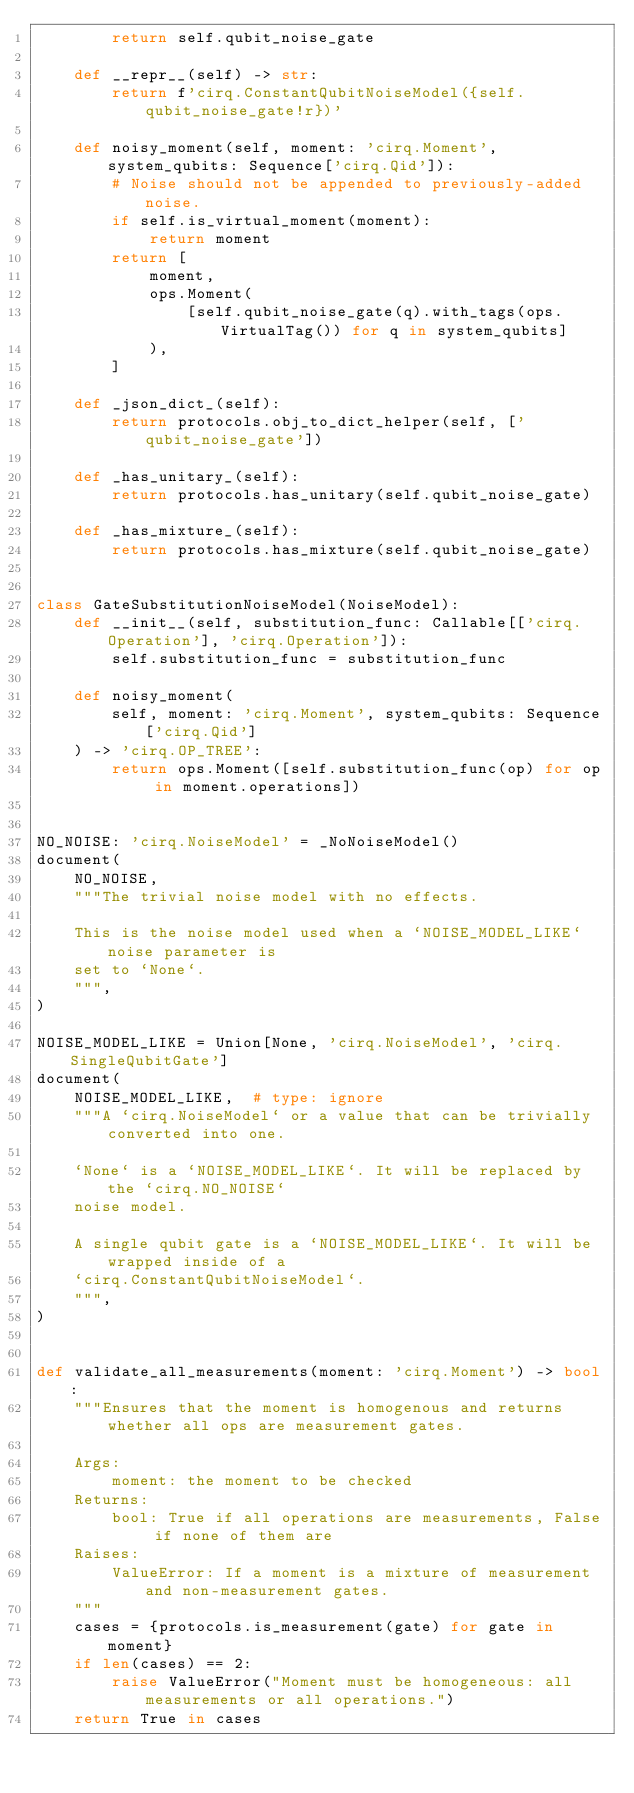<code> <loc_0><loc_0><loc_500><loc_500><_Python_>        return self.qubit_noise_gate

    def __repr__(self) -> str:
        return f'cirq.ConstantQubitNoiseModel({self.qubit_noise_gate!r})'

    def noisy_moment(self, moment: 'cirq.Moment', system_qubits: Sequence['cirq.Qid']):
        # Noise should not be appended to previously-added noise.
        if self.is_virtual_moment(moment):
            return moment
        return [
            moment,
            ops.Moment(
                [self.qubit_noise_gate(q).with_tags(ops.VirtualTag()) for q in system_qubits]
            ),
        ]

    def _json_dict_(self):
        return protocols.obj_to_dict_helper(self, ['qubit_noise_gate'])

    def _has_unitary_(self):
        return protocols.has_unitary(self.qubit_noise_gate)

    def _has_mixture_(self):
        return protocols.has_mixture(self.qubit_noise_gate)


class GateSubstitutionNoiseModel(NoiseModel):
    def __init__(self, substitution_func: Callable[['cirq.Operation'], 'cirq.Operation']):
        self.substitution_func = substitution_func

    def noisy_moment(
        self, moment: 'cirq.Moment', system_qubits: Sequence['cirq.Qid']
    ) -> 'cirq.OP_TREE':
        return ops.Moment([self.substitution_func(op) for op in moment.operations])


NO_NOISE: 'cirq.NoiseModel' = _NoNoiseModel()
document(
    NO_NOISE,
    """The trivial noise model with no effects.

    This is the noise model used when a `NOISE_MODEL_LIKE` noise parameter is
    set to `None`.
    """,
)

NOISE_MODEL_LIKE = Union[None, 'cirq.NoiseModel', 'cirq.SingleQubitGate']
document(
    NOISE_MODEL_LIKE,  # type: ignore
    """A `cirq.NoiseModel` or a value that can be trivially converted into one.

    `None` is a `NOISE_MODEL_LIKE`. It will be replaced by the `cirq.NO_NOISE`
    noise model.

    A single qubit gate is a `NOISE_MODEL_LIKE`. It will be wrapped inside of a
    `cirq.ConstantQubitNoiseModel`.
    """,
)


def validate_all_measurements(moment: 'cirq.Moment') -> bool:
    """Ensures that the moment is homogenous and returns whether all ops are measurement gates.

    Args:
        moment: the moment to be checked
    Returns:
        bool: True if all operations are measurements, False if none of them are
    Raises:
        ValueError: If a moment is a mixture of measurement and non-measurement gates.
    """
    cases = {protocols.is_measurement(gate) for gate in moment}
    if len(cases) == 2:
        raise ValueError("Moment must be homogeneous: all measurements or all operations.")
    return True in cases
</code> 